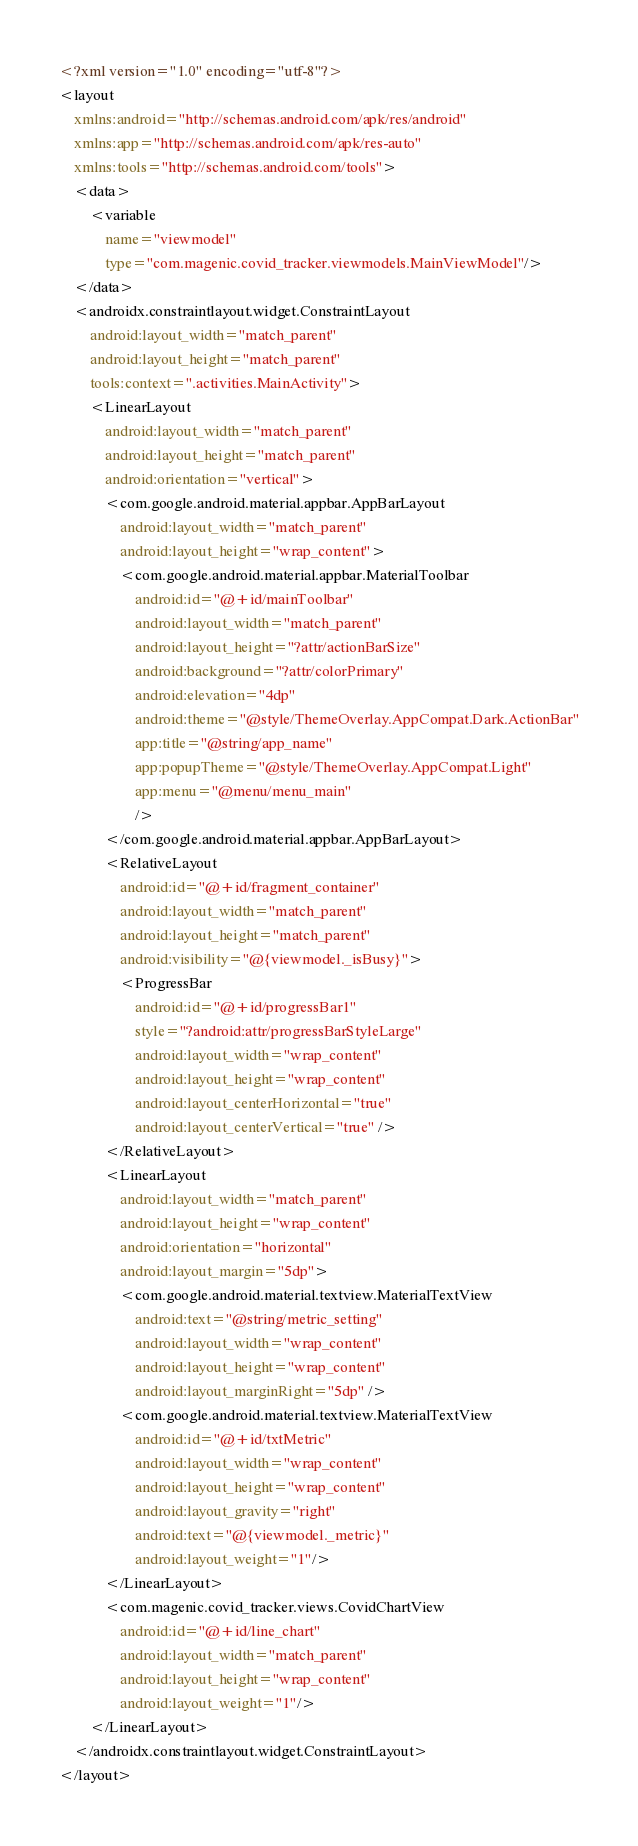<code> <loc_0><loc_0><loc_500><loc_500><_XML_><?xml version="1.0" encoding="utf-8"?>
<layout
    xmlns:android="http://schemas.android.com/apk/res/android"
    xmlns:app="http://schemas.android.com/apk/res-auto"
    xmlns:tools="http://schemas.android.com/tools">
    <data>
        <variable
            name="viewmodel"
            type="com.magenic.covid_tracker.viewmodels.MainViewModel"/>
    </data>
    <androidx.constraintlayout.widget.ConstraintLayout
        android:layout_width="match_parent"
        android:layout_height="match_parent"
        tools:context=".activities.MainActivity">
        <LinearLayout
            android:layout_width="match_parent"
            android:layout_height="match_parent"
            android:orientation="vertical">
            <com.google.android.material.appbar.AppBarLayout
                android:layout_width="match_parent"
                android:layout_height="wrap_content">
                <com.google.android.material.appbar.MaterialToolbar
                    android:id="@+id/mainToolbar"
                    android:layout_width="match_parent"
                    android:layout_height="?attr/actionBarSize"
                    android:background="?attr/colorPrimary"
                    android:elevation="4dp"
                    android:theme="@style/ThemeOverlay.AppCompat.Dark.ActionBar"
                    app:title="@string/app_name"
                    app:popupTheme="@style/ThemeOverlay.AppCompat.Light"
                    app:menu="@menu/menu_main"
                    />
            </com.google.android.material.appbar.AppBarLayout>
            <RelativeLayout
                android:id="@+id/fragment_container"
                android:layout_width="match_parent"
                android:layout_height="match_parent"
                android:visibility="@{viewmodel._isBusy}">
                <ProgressBar
                    android:id="@+id/progressBar1"
                    style="?android:attr/progressBarStyleLarge"
                    android:layout_width="wrap_content"
                    android:layout_height="wrap_content"
                    android:layout_centerHorizontal="true"
                    android:layout_centerVertical="true" />
            </RelativeLayout>
            <LinearLayout
                android:layout_width="match_parent"
                android:layout_height="wrap_content"
                android:orientation="horizontal"
                android:layout_margin="5dp">
                <com.google.android.material.textview.MaterialTextView
                    android:text="@string/metric_setting"
                    android:layout_width="wrap_content"
                    android:layout_height="wrap_content"
                    android:layout_marginRight="5dp" />
                <com.google.android.material.textview.MaterialTextView
                    android:id="@+id/txtMetric"
                    android:layout_width="wrap_content"
                    android:layout_height="wrap_content"
                    android:layout_gravity="right"
                    android:text="@{viewmodel._metric}"
                    android:layout_weight="1"/>
            </LinearLayout>
            <com.magenic.covid_tracker.views.CovidChartView
                android:id="@+id/line_chart"
                android:layout_width="match_parent"
                android:layout_height="wrap_content"
                android:layout_weight="1"/>
        </LinearLayout>
    </androidx.constraintlayout.widget.ConstraintLayout>
</layout></code> 